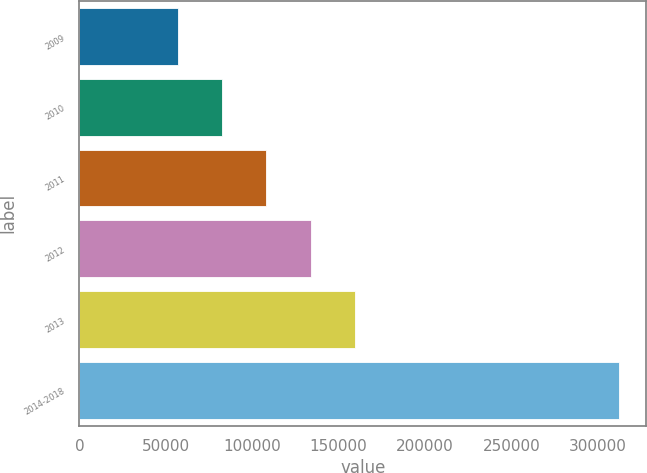Convert chart. <chart><loc_0><loc_0><loc_500><loc_500><bar_chart><fcel>2009<fcel>2010<fcel>2011<fcel>2012<fcel>2013<fcel>2014-2018<nl><fcel>57250<fcel>82770.3<fcel>108291<fcel>133811<fcel>159331<fcel>312453<nl></chart> 